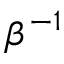<formula> <loc_0><loc_0><loc_500><loc_500>\beta ^ { - 1 }</formula> 